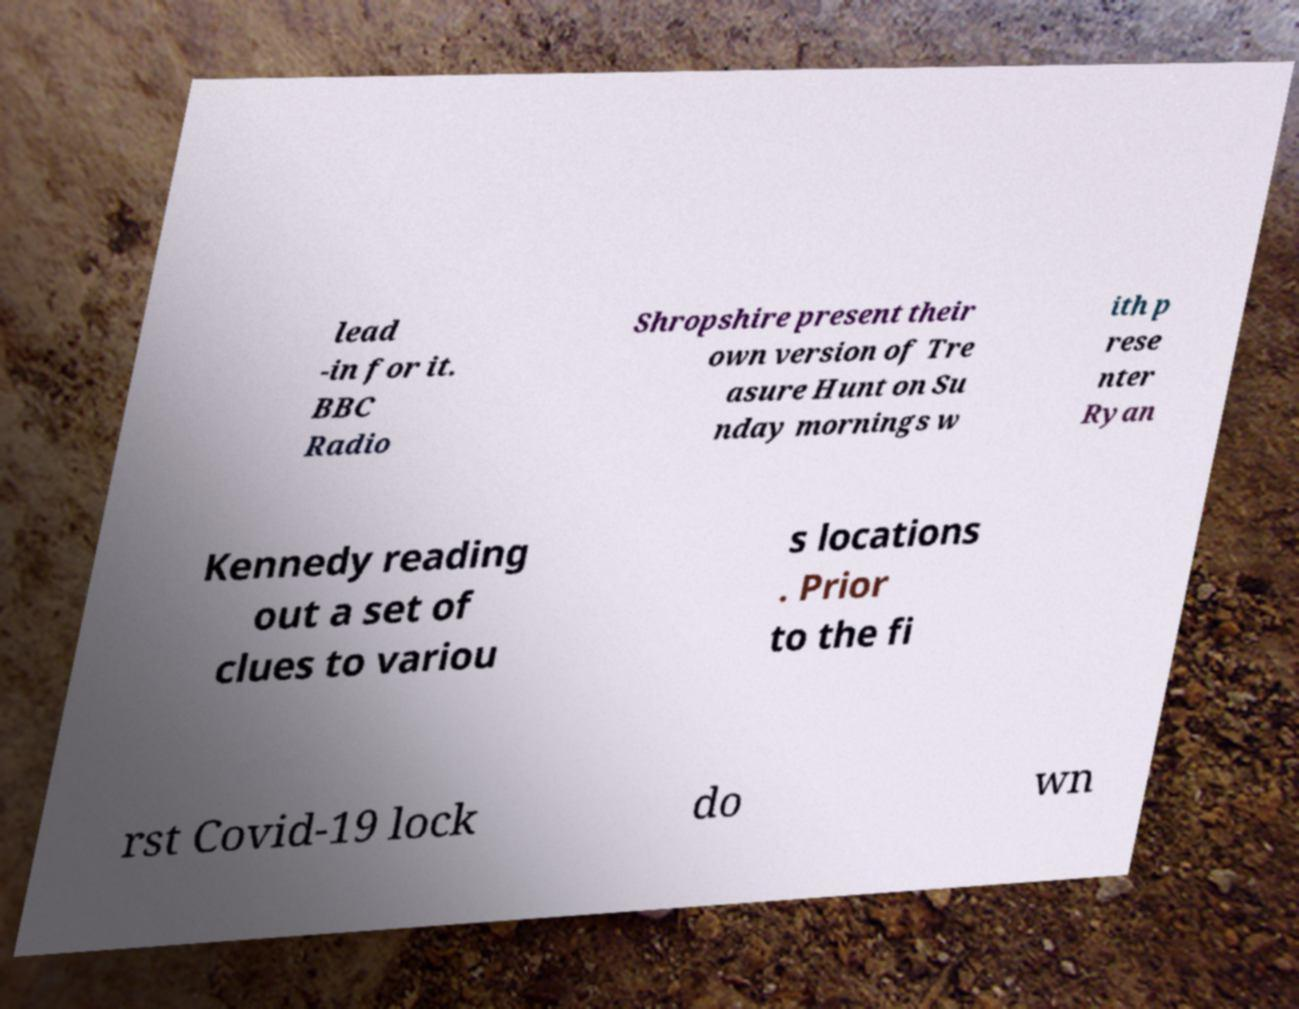Can you read and provide the text displayed in the image?This photo seems to have some interesting text. Can you extract and type it out for me? lead -in for it. BBC Radio Shropshire present their own version of Tre asure Hunt on Su nday mornings w ith p rese nter Ryan Kennedy reading out a set of clues to variou s locations . Prior to the fi rst Covid-19 lock do wn 